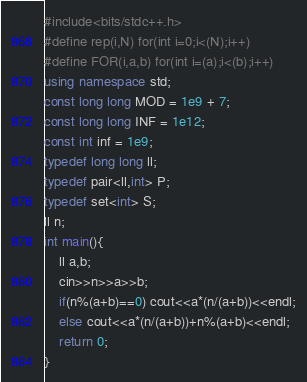<code> <loc_0><loc_0><loc_500><loc_500><_C++_>#include<bits/stdc++.h>
#define rep(i,N) for(int i=0;i<(N);i++)
#define FOR(i,a,b) for(int i=(a);i<(b);i++)
using namespace std;
const long long MOD = 1e9 + 7;
const long long INF = 1e12;
const int inf = 1e9;
typedef long long ll;
typedef pair<ll,int> P;
typedef set<int> S;
ll n;
int main(){
    ll a,b;
    cin>>n>>a>>b;
    if(n%(a+b)==0) cout<<a*(n/(a+b))<<endl;
    else cout<<a*(n/(a+b))+n%(a+b)<<endl;
    return 0;
}</code> 